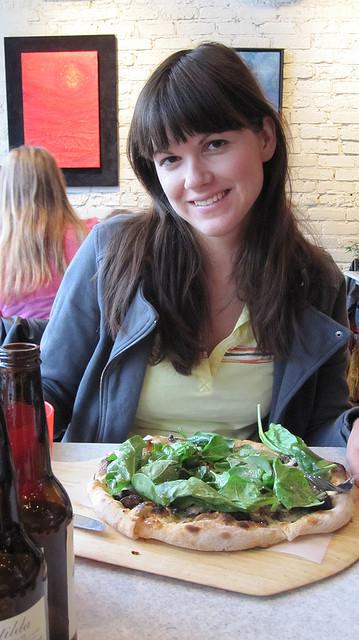Is that a man or woman holding the food?
Give a very brief answer. Woman. Is the food being served on a metal tray?
Give a very brief answer. No. What color jacket is the person wearing?
Quick response, please. Blue. Is she using excellent table manners?
Keep it brief. Yes. How many pizzas are there?
Give a very brief answer. 1. Is the woman wearing glasses?
Keep it brief. No. Are they eating a vegan meal?
Write a very short answer. Yes. What is she about to eat?
Concise answer only. Pizza. Is she in a restaurant?
Short answer required. Yes. What is the girl eating?
Write a very short answer. Pizza. What color are the walls?
Concise answer only. White. Does she have bangs?
Write a very short answer. Yes. What is the woman drinking with her lunch?
Answer briefly. Beer. Is this a personal sized pizza?
Answer briefly. Yes. Is the woman eating a dessert?
Write a very short answer. No. What vegetable is shown in this photograph?
Concise answer only. Spinach. What color is her jacket?
Give a very brief answer. Blue. Is the blonde or the brunette in charge of chopping the food?
Quick response, please. Brunette. 